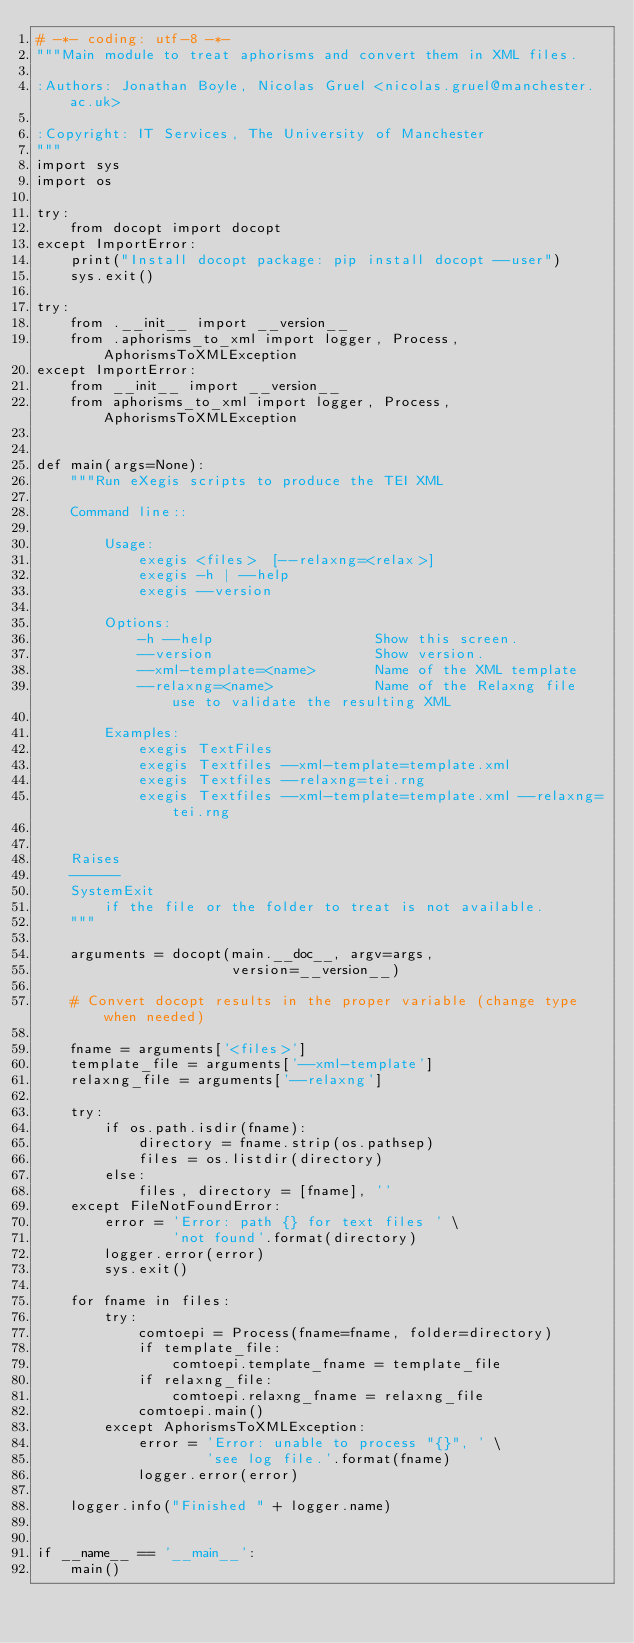<code> <loc_0><loc_0><loc_500><loc_500><_Python_># -*- coding: utf-8 -*-
"""Main module to treat aphorisms and convert them in XML files.

:Authors: Jonathan Boyle, Nicolas Gruel <nicolas.gruel@manchester.ac.uk>

:Copyright: IT Services, The University of Manchester
"""
import sys
import os

try:
    from docopt import docopt
except ImportError:
    print("Install docopt package: pip install docopt --user")
    sys.exit()

try:
    from .__init__ import __version__
    from .aphorisms_to_xml import logger, Process, AphorismsToXMLException
except ImportError:
    from __init__ import __version__
    from aphorisms_to_xml import logger, Process, AphorismsToXMLException


def main(args=None):
    """Run eXegis scripts to produce the TEI XML

    Command line::

        Usage:
            exegis <files>  [--relaxng=<relax>]
            exegis -h | --help
            exegis --version

        Options:
            -h --help                   Show this screen.
            --version                   Show version.
            --xml-template=<name>       Name of the XML template
            --relaxng=<name>            Name of the Relaxng file use to validate the resulting XML

        Examples:
            exegis TextFiles
            exegis Textfiles --xml-template=template.xml
            exegis Textfiles --relaxng=tei.rng
            exegis Textfiles --xml-template=template.xml --relaxng=tei.rng


    Raises
    ------
    SystemExit
        if the file or the folder to treat is not available.
    """

    arguments = docopt(main.__doc__, argv=args,
                       version=__version__)

    # Convert docopt results in the proper variable (change type when needed)

    fname = arguments['<files>']
    template_file = arguments['--xml-template']
    relaxng_file = arguments['--relaxng']

    try:
        if os.path.isdir(fname):
            directory = fname.strip(os.pathsep)
            files = os.listdir(directory)
        else:
            files, directory = [fname], ''
    except FileNotFoundError:
        error = 'Error: path {} for text files ' \
                'not found'.format(directory)
        logger.error(error)
        sys.exit()

    for fname in files:
        try:
            comtoepi = Process(fname=fname, folder=directory)
            if template_file:
                comtoepi.template_fname = template_file
            if relaxng_file:
                comtoepi.relaxng_fname = relaxng_file
            comtoepi.main()
        except AphorismsToXMLException:
            error = 'Error: unable to process "{}", ' \
                    'see log file.'.format(fname)
            logger.error(error)

    logger.info("Finished " + logger.name)


if __name__ == '__main__':
    main()
</code> 